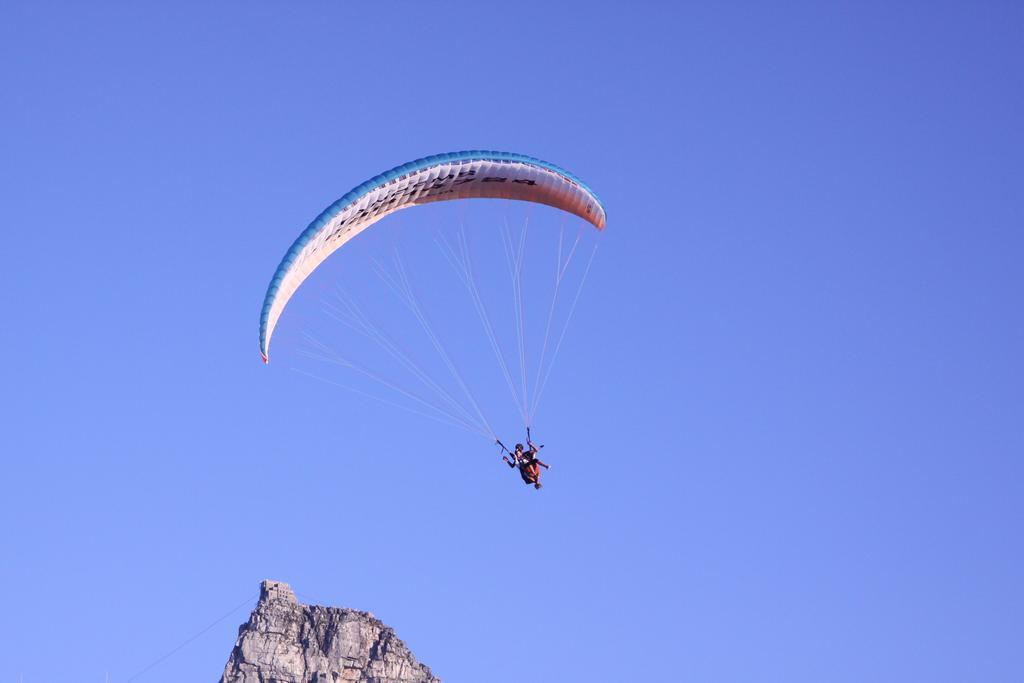Can you describe this image briefly? In this image, there is a hill and at the top, we can see a person wearing parachute. 